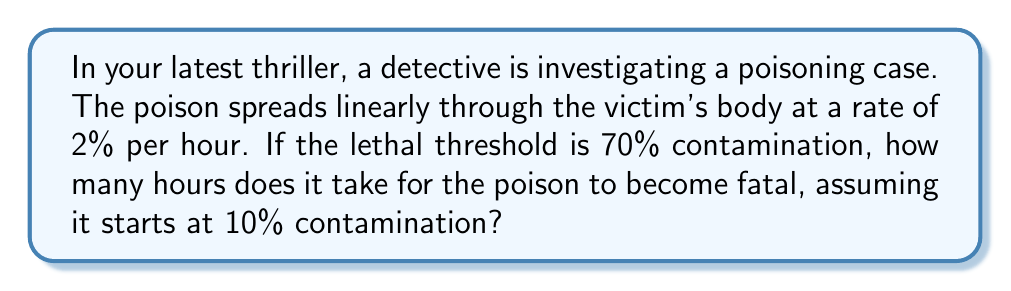Can you solve this math problem? Let's approach this step-by-step using a linear equation:

1) Let $y$ represent the percentage of contamination and $x$ represent the number of hours.

2) We can write the linear equation as:
   $y = mx + b$
   where $m$ is the rate of change (2% per hour) and $b$ is the initial contamination (10%).

3) Substituting the values:
   $y = 2x + 10$

4) We want to find $x$ when $y = 70$ (the lethal threshold):
   $70 = 2x + 10$

5) Solving for $x$:
   $60 = 2x$
   $x = 30$

6) Therefore, it takes 30 hours for the poison to reach the lethal threshold.

To verify:
Initial contamination: 10%
After 30 hours: $10 + (2 * 30) = 70%$
Answer: 30 hours 